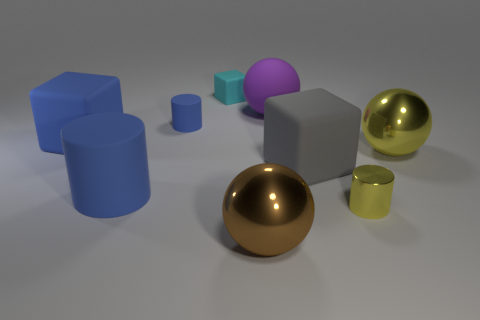Is the purple object the same shape as the cyan thing?
Provide a short and direct response. No. There is a metal ball behind the big sphere in front of the matte object that is right of the large purple ball; what is its size?
Your response must be concise. Large. Is there a blue cylinder on the left side of the big matte block on the left side of the big brown thing?
Offer a very short reply. No. How many matte cylinders are right of the rubber cylinder left of the small cylinder to the left of the small cyan rubber object?
Make the answer very short. 1. What is the color of the large object that is both in front of the gray block and behind the large brown ball?
Make the answer very short. Blue. What number of matte balls have the same color as the tiny rubber cube?
Your answer should be very brief. 0. What number of cubes are large blue rubber objects or big yellow objects?
Your response must be concise. 1. What color is the cube that is the same size as the gray rubber object?
Provide a short and direct response. Blue. There is a big metal object that is behind the big metallic sphere that is on the left side of the tiny shiny cylinder; is there a tiny blue thing in front of it?
Ensure brevity in your answer.  No. What size is the cyan cube?
Your answer should be very brief. Small. 